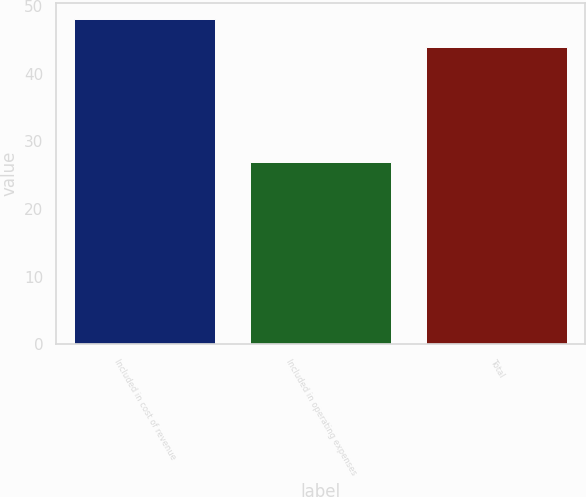Convert chart to OTSL. <chart><loc_0><loc_0><loc_500><loc_500><bar_chart><fcel>Included in cost of revenue<fcel>Included in operating expenses<fcel>Total<nl><fcel>48<fcel>27<fcel>44<nl></chart> 